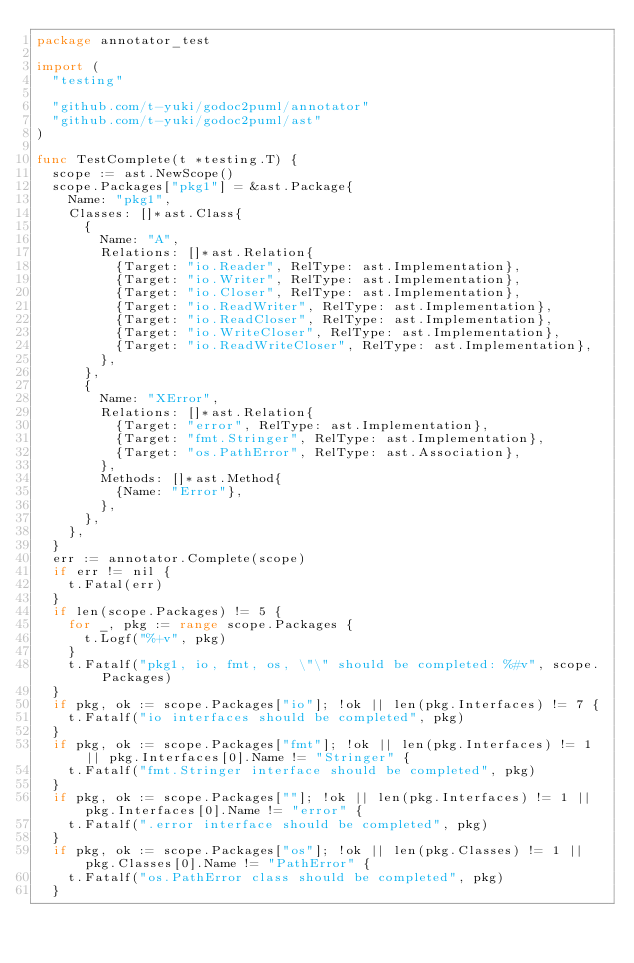Convert code to text. <code><loc_0><loc_0><loc_500><loc_500><_Go_>package annotator_test

import (
	"testing"

	"github.com/t-yuki/godoc2puml/annotator"
	"github.com/t-yuki/godoc2puml/ast"
)

func TestComplete(t *testing.T) {
	scope := ast.NewScope()
	scope.Packages["pkg1"] = &ast.Package{
		Name: "pkg1",
		Classes: []*ast.Class{
			{
				Name: "A",
				Relations: []*ast.Relation{
					{Target: "io.Reader", RelType: ast.Implementation},
					{Target: "io.Writer", RelType: ast.Implementation},
					{Target: "io.Closer", RelType: ast.Implementation},
					{Target: "io.ReadWriter", RelType: ast.Implementation},
					{Target: "io.ReadCloser", RelType: ast.Implementation},
					{Target: "io.WriteCloser", RelType: ast.Implementation},
					{Target: "io.ReadWriteCloser", RelType: ast.Implementation},
				},
			},
			{
				Name: "XError",
				Relations: []*ast.Relation{
					{Target: "error", RelType: ast.Implementation},
					{Target: "fmt.Stringer", RelType: ast.Implementation},
					{Target: "os.PathError", RelType: ast.Association},
				},
				Methods: []*ast.Method{
					{Name: "Error"},
				},
			},
		},
	}
	err := annotator.Complete(scope)
	if err != nil {
		t.Fatal(err)
	}
	if len(scope.Packages) != 5 {
		for _, pkg := range scope.Packages {
			t.Logf("%+v", pkg)
		}
		t.Fatalf("pkg1, io, fmt, os, \"\" should be completed: %#v", scope.Packages)
	}
	if pkg, ok := scope.Packages["io"]; !ok || len(pkg.Interfaces) != 7 {
		t.Fatalf("io interfaces should be completed", pkg)
	}
	if pkg, ok := scope.Packages["fmt"]; !ok || len(pkg.Interfaces) != 1 || pkg.Interfaces[0].Name != "Stringer" {
		t.Fatalf("fmt.Stringer interface should be completed", pkg)
	}
	if pkg, ok := scope.Packages[""]; !ok || len(pkg.Interfaces) != 1 || pkg.Interfaces[0].Name != "error" {
		t.Fatalf(".error interface should be completed", pkg)
	}
	if pkg, ok := scope.Packages["os"]; !ok || len(pkg.Classes) != 1 || pkg.Classes[0].Name != "PathError" {
		t.Fatalf("os.PathError class should be completed", pkg)
	}</code> 